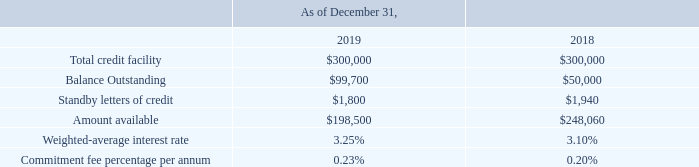Results of Operations: Years Ended December 31, 2018, versus Year Ended December 31, 2017 (Amounts in thousands, except percentages and per share amounts):
Capital Resources
Long-term debt was comprised of the following:
On February 12, 2019, we entered into an amended and restated five-year Credit Agreement with a group of banks (the "Credit Agreement") to extend the term of the facility. The Credit Agreement provides for a revolving credit facility of $300,000, which may be increased by $150,000 at the request of the Company, subject to the administrative agent's approval. This new unsecured credit facility replaces the prior $300,000 unsecured credit facility, which would have expired August 10, 2020. Borrowings of $50,000 under the prior credit agreement were refinanced into the Credit Agreement. The prior agreement was terminated as of February 12, 2019.
The Revolving Credit Facility includes a swing line sublimit of $15,000 and a letter of credit sublimit of $10,000. Borrowings under the Revolving Credit Facility bear interest at the base rate defined in the Credit Agreement. We also pay a quarterly commitment fee on the unused portion of the Revolving Credit Facility. The commitment fee ranges from 0.20% to 0.30% based on the our total leverage ratio.
We have entered into interest rate swap agreements to fix interest rates on $50,000 of long-term debt through February 2024. The difference to be paid or received under the terms of the swap agreements is recognized as an adjustment to interest expense when settled.
We have historically funded our capital and operating needs primarily through cash flows from operating activities, supported by available credit under our Revolving Credit Facility. We believe that cash flows from operating activities and available borrowings under our Revolving Credit Facility will be adequate to fund our working capital needs, capital expenditures, and debt service requirements for at least the next twelve months. However, we may choose to pursue additional equity and debt financing to provide additional liquidity or to fund acquisitions.
What does the Credit Agreement provide for? Revolving credit facility of $300,000, which may be increased by $150,000 at the request of the company, subject to the administrative agent's approval. What was the Total credit facility in 2019?
Answer scale should be: thousand. 300,000. What was the Standby letters of credit in 2018?
Answer scale should be: thousand. 1,940. What was the change in balance outstanding between 2018 and 2019?
Answer scale should be: thousand. 99,700-50,000
Answer: 49700. What was the change in the Weighted-average interest rate between 2018 and 2019?
Answer scale should be: percent. 3.25-3.10
Answer: 0.15. What was the percentage change in the amount available between 2018 and 2019?
Answer scale should be: percent. (198,500-248,060)/248,060
Answer: -19.98. 